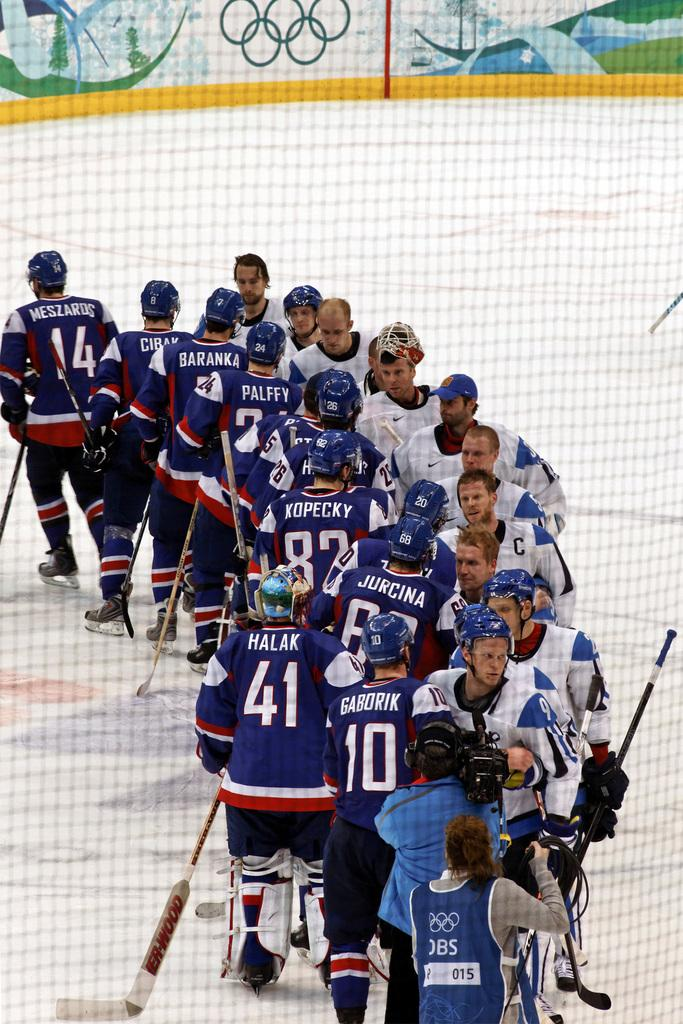<image>
Relay a brief, clear account of the picture shown. Hockey players on a rinks shaking hands and some wear numbered jerseys like 41 and 10 